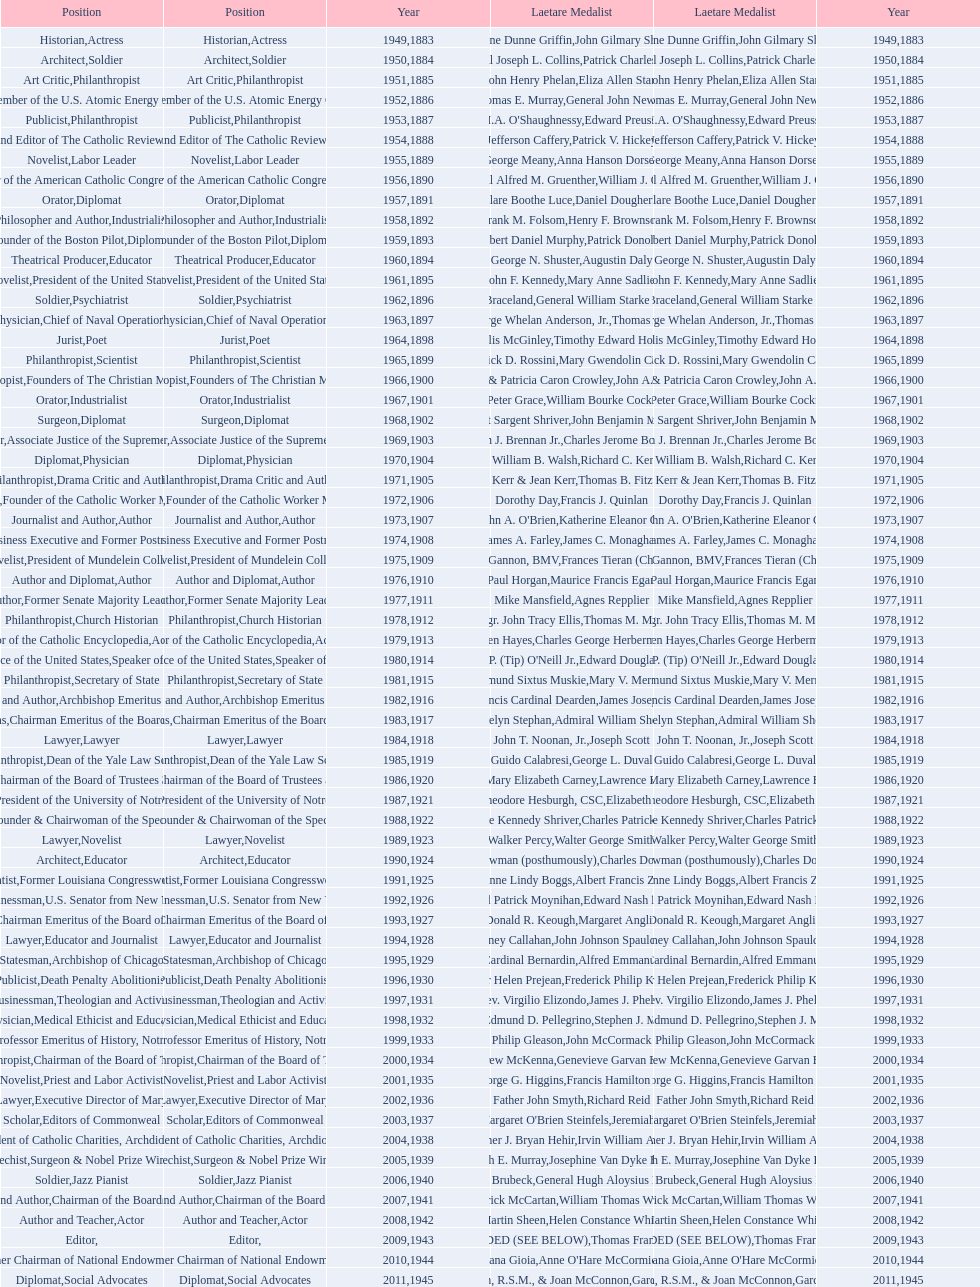How many are or were journalists? 5. 